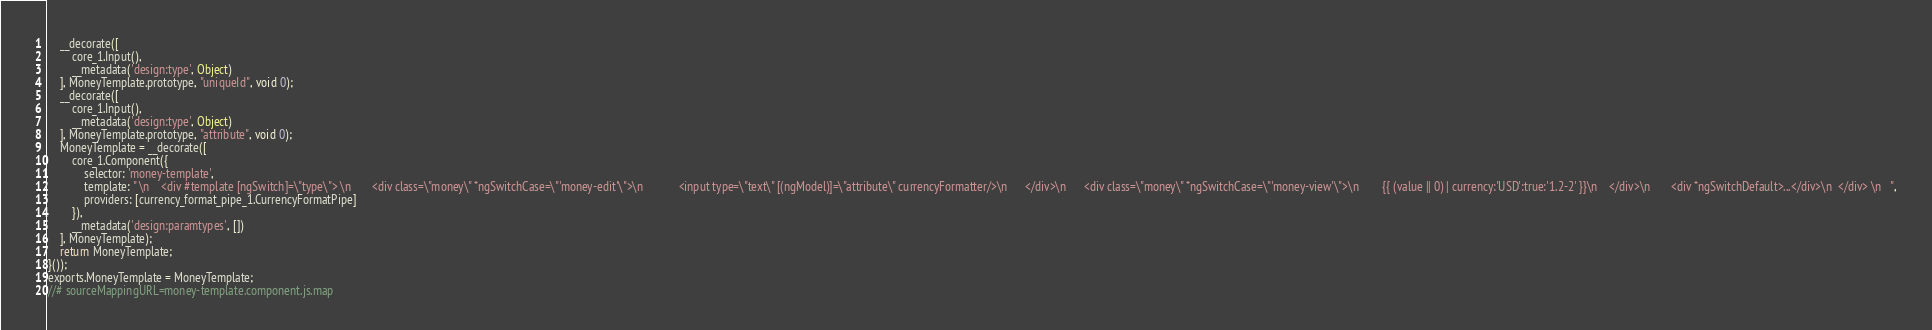Convert code to text. <code><loc_0><loc_0><loc_500><loc_500><_JavaScript_>    __decorate([
        core_1.Input(), 
        __metadata('design:type', Object)
    ], MoneyTemplate.prototype, "uniqueId", void 0);
    __decorate([
        core_1.Input(), 
        __metadata('design:type', Object)
    ], MoneyTemplate.prototype, "attribute", void 0);
    MoneyTemplate = __decorate([
        core_1.Component({
            selector: 'money-template',
            template: " \n    <div #template [ngSwitch]=\"type\"> \n       <div class=\"money\" *ngSwitchCase=\"'money-edit'\">\n            <input type=\"text\" [(ngModel)]=\"attribute\" currencyFormatter/>\n      </div>\n      <div class=\"money\" *ngSwitchCase=\"'money-view'\">\n        {{ (value || 0) | currency:'USD':true:'1.2-2' }}\n    </div>\n       <div *ngSwitchDefault>...</div>\n  </div> \n   ",
            providers: [currency_format_pipe_1.CurrencyFormatPipe]
        }), 
        __metadata('design:paramtypes', [])
    ], MoneyTemplate);
    return MoneyTemplate;
}());
exports.MoneyTemplate = MoneyTemplate;
//# sourceMappingURL=money-template.component.js.map</code> 